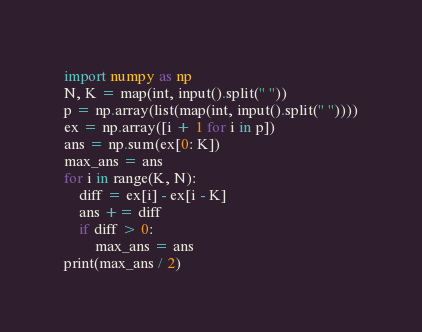<code> <loc_0><loc_0><loc_500><loc_500><_Python_>import numpy as np
N, K = map(int, input().split(" "))
p = np.array(list(map(int, input().split(" "))))
ex = np.array([i + 1 for i in p])
ans = np.sum(ex[0: K])
max_ans = ans
for i in range(K, N):
    diff = ex[i] - ex[i - K]
    ans += diff
    if diff > 0:
        max_ans = ans
print(max_ans / 2)</code> 